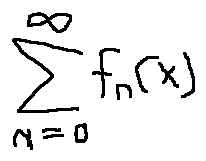Convert formula to latex. <formula><loc_0><loc_0><loc_500><loc_500>\sum \lim i t s _ { n = 0 } ^ { \infty } f _ { n } ( x )</formula> 